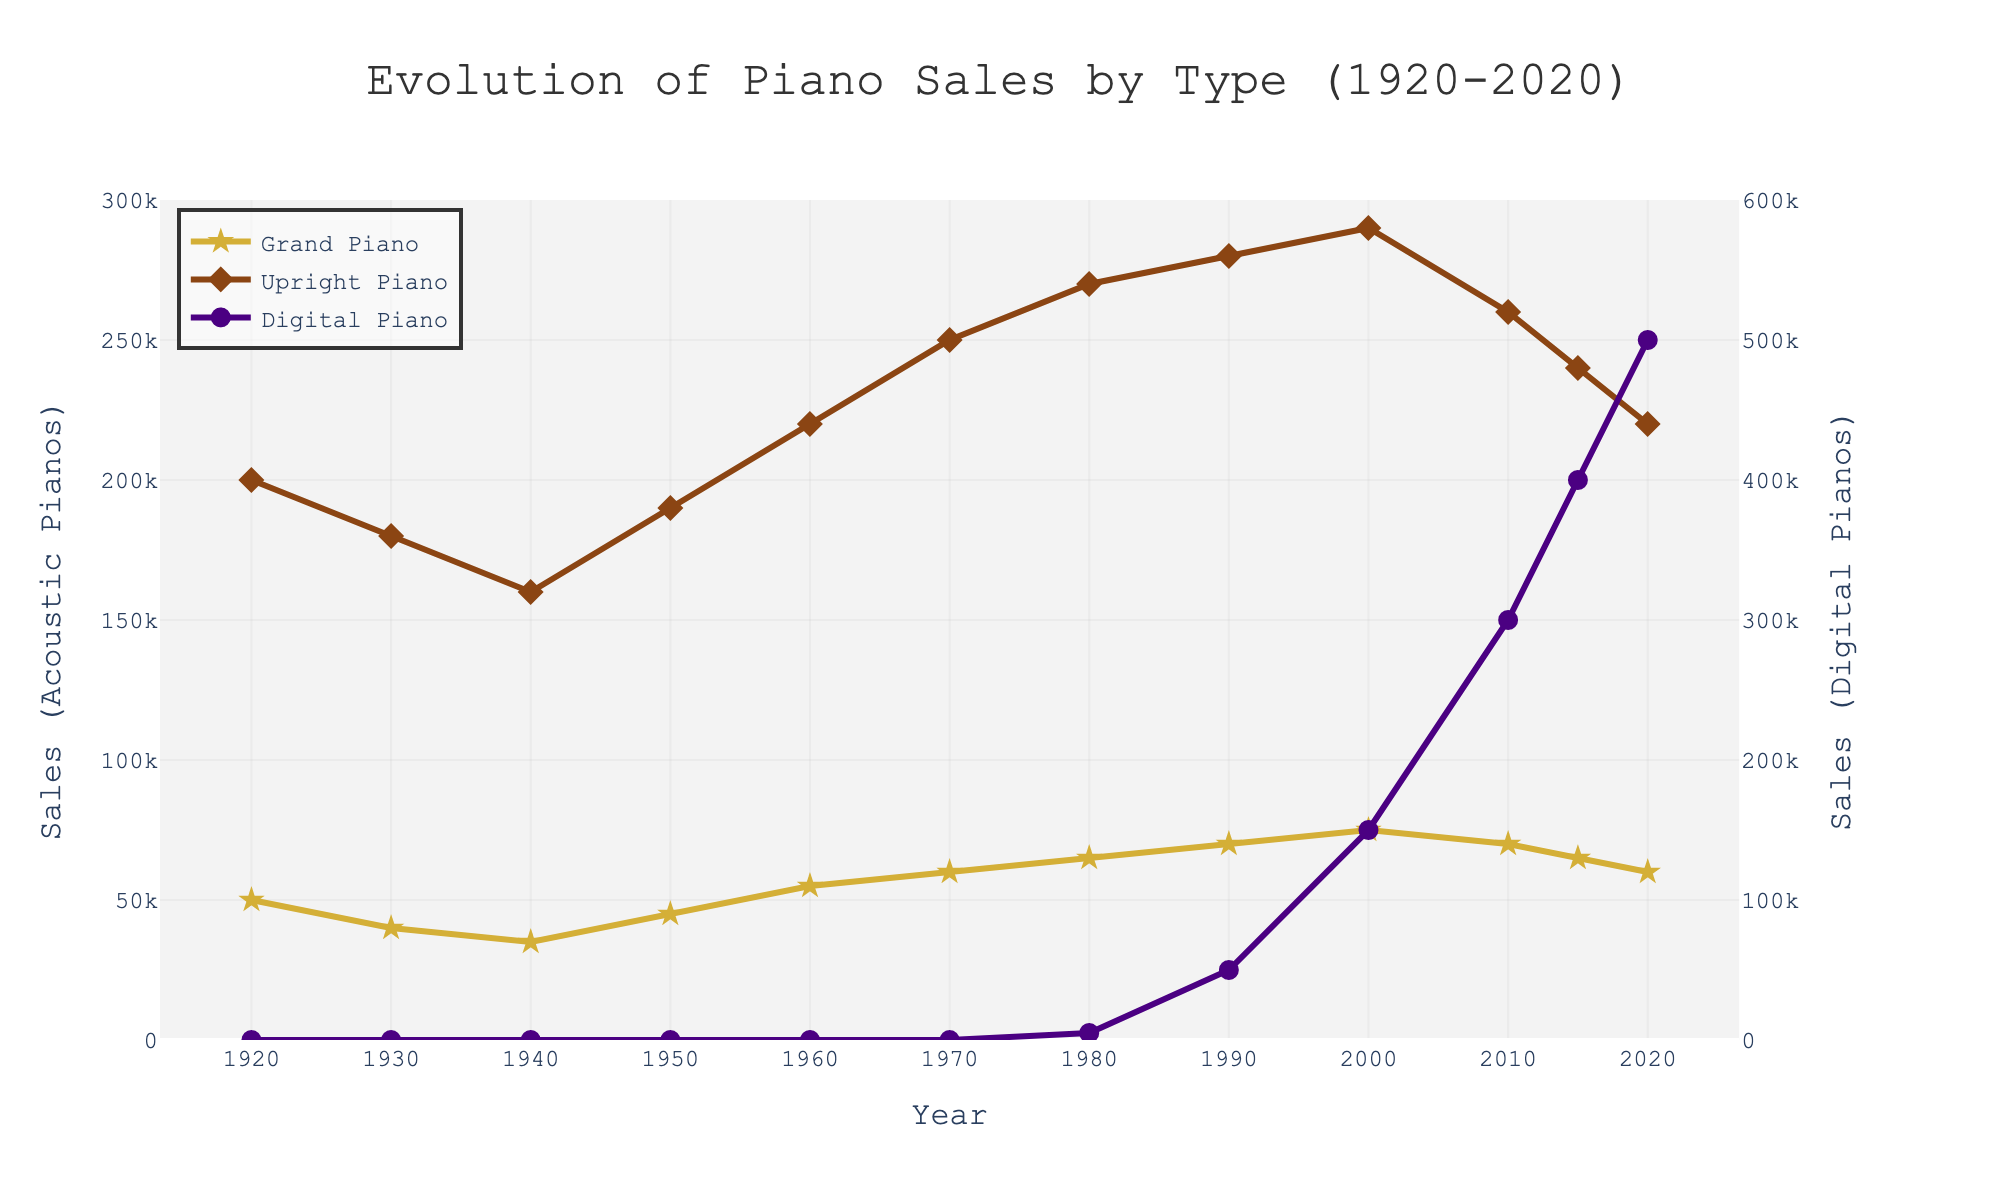What year did digital piano sales surpass upright piano sales? To determine this, find the year when the digital piano line on the chart rises above the upright piano line. This occurs in 2015.
Answer: 2015 Which type of piano had the highest sales in 1990? The chart shows three lines for different types of pianos. In 1990, the upright piano line is the highest compared to the grand and digital pianos.
Answer: Upright Piano How did the sales trend of grand pianos change from 1960 to 2020? Observe the grand piano line from 1960 to 2020. It initially rises, peaking around 1980, and then gradually declines until 2020.
Answer: Increased then decreased What is the sum of grand piano and upright piano sales in 1970? Look at the sales values in 1970: grand piano sales are 60,000, and upright piano sales are 250,000. Adding these gives 60,000 + 250,000 = 310,000.
Answer: 310,000 Which type of piano showed the most significant increase in sales between 1980 and 2010? Compare the slopes of the three lines. The digital piano line shows the steepest increase, from 5,000 to 300,000.
Answer: Digital Piano In which year did grand piano sales peak, and what was the value? Look for the highest point on the grand piano line, which peaks in 2000 with a value of 75,000.
Answer: 2000, 75,000 How much did upright piano sales decrease from their peak to 2020? The peak sales for upright pianos are 290,000 in 2000. By 2020, they decreased to 220,000. The difference is 290,000 - 220,000 = 70,000.
Answer: 70,000 Compare the sales trend of digital pianos to upright pianos from 2000 to 2020? From 2000 to 2020, digital piano sales sharply increased from 150,000 to 500,000, while upright piano sales declined from 290,000 to 220,000.
Answer: Digital increased; Upright decreased What were the sales of digital pianos in 1980, and how do they compare to grand piano sales in the same year? In 1980, digital pianos had sales of 5,000, while grand pianos had sales of 65,000. This shows that grand pianos outsold digital pianos by a large margin.
Answer: 5,000; Grand Piano was higher 